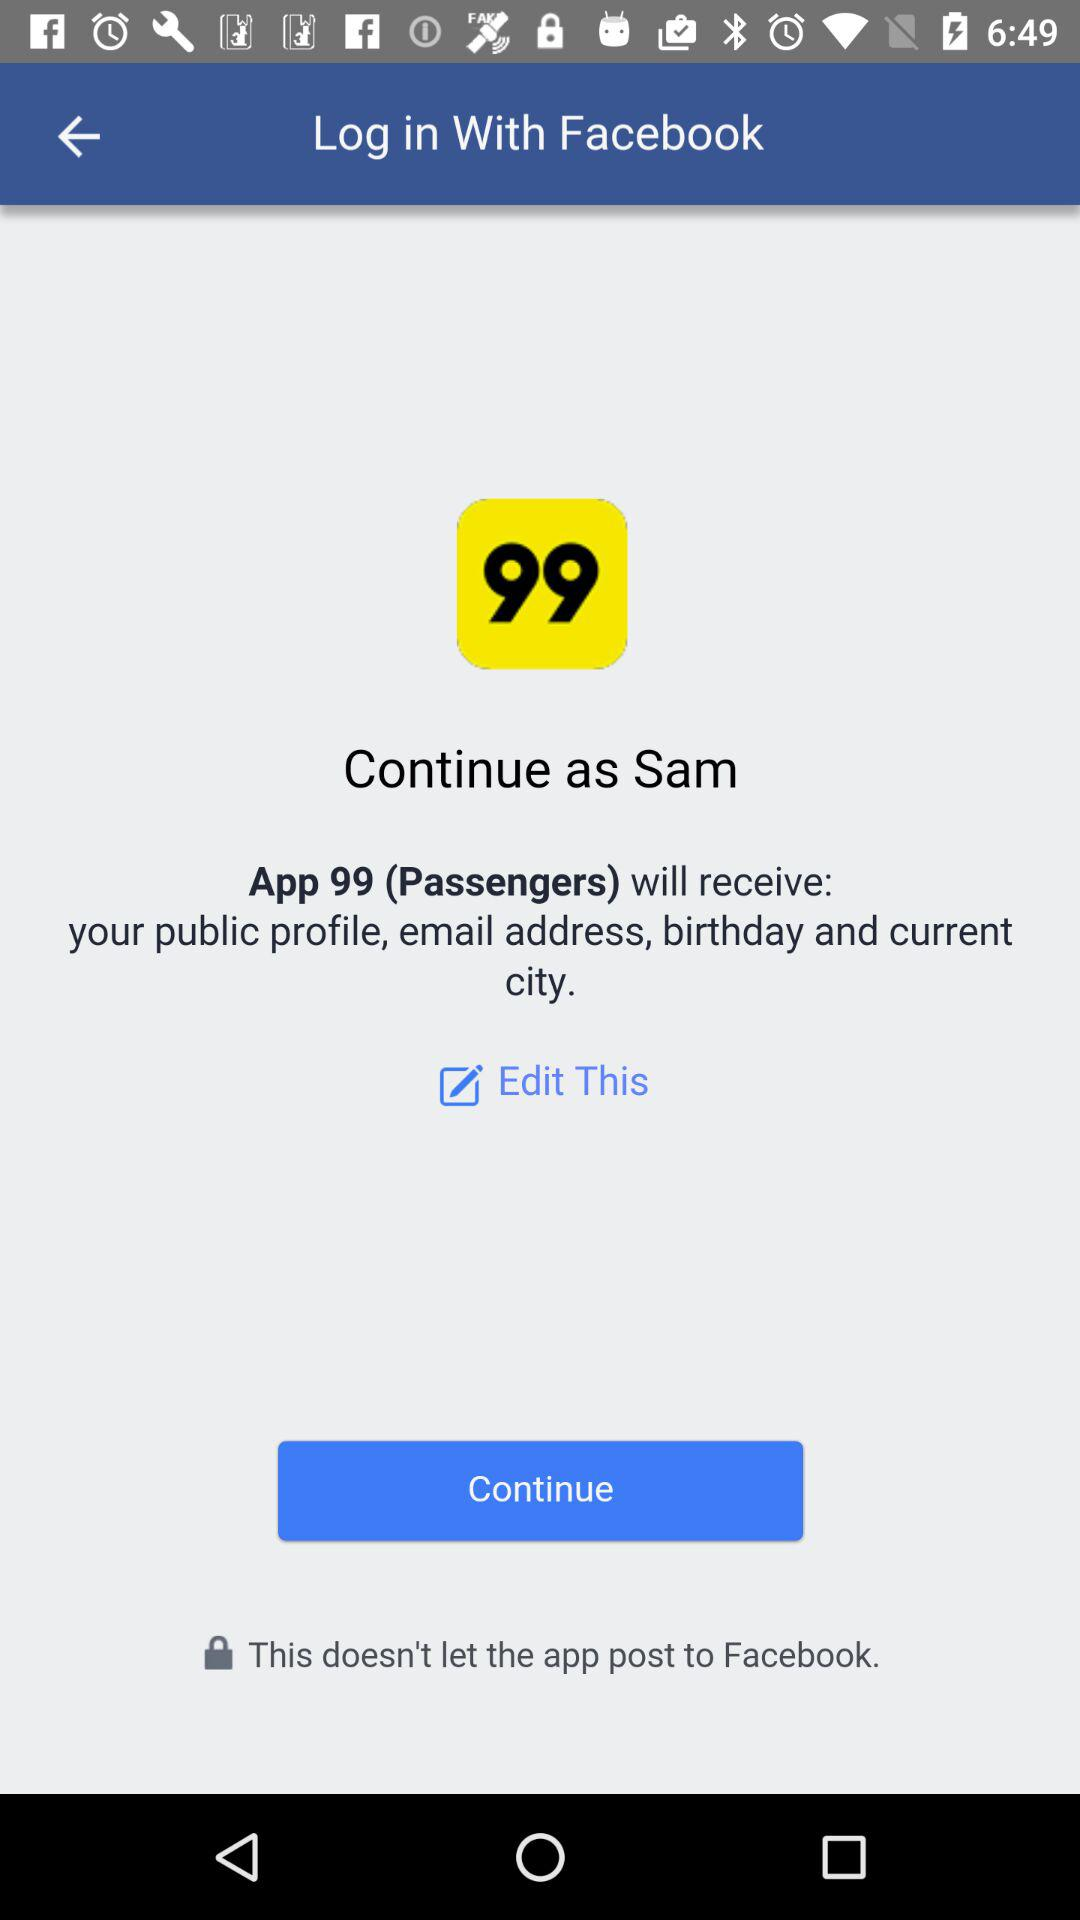What is the name of the user? The name of the user is "Sam". 